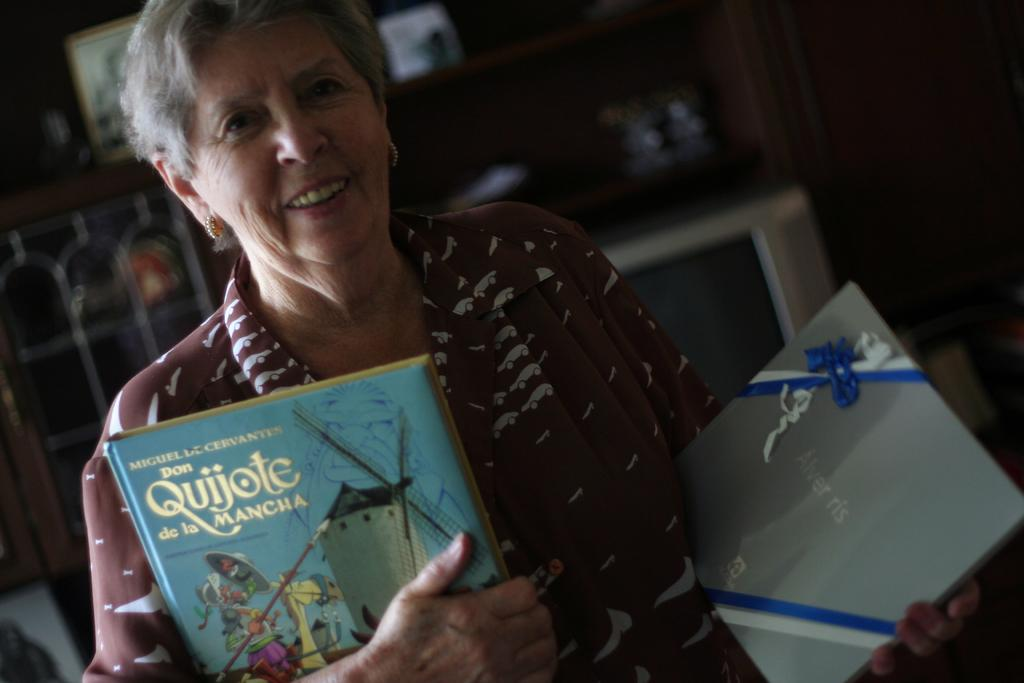What is the main subject of the image? The main subject of the image is a woman. What is the woman holding in the image? The woman is holding books. Can you describe the lighting condition in the image? The image is a little dark. How many spiders are crawling on the books in the image? There are no spiders visible in the image. What type of steam can be seen coming from the books in the image? There is no steam present in the image. What shape is the woman's face in the image? The provided facts do not give information about the shape of the woman's face. 